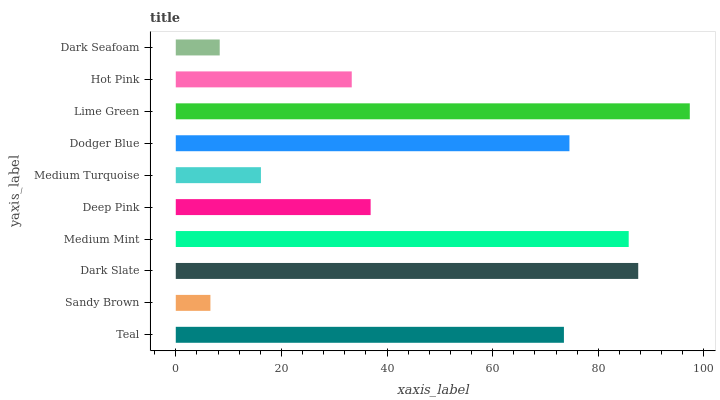Is Sandy Brown the minimum?
Answer yes or no. Yes. Is Lime Green the maximum?
Answer yes or no. Yes. Is Dark Slate the minimum?
Answer yes or no. No. Is Dark Slate the maximum?
Answer yes or no. No. Is Dark Slate greater than Sandy Brown?
Answer yes or no. Yes. Is Sandy Brown less than Dark Slate?
Answer yes or no. Yes. Is Sandy Brown greater than Dark Slate?
Answer yes or no. No. Is Dark Slate less than Sandy Brown?
Answer yes or no. No. Is Teal the high median?
Answer yes or no. Yes. Is Deep Pink the low median?
Answer yes or no. Yes. Is Medium Turquoise the high median?
Answer yes or no. No. Is Medium Mint the low median?
Answer yes or no. No. 